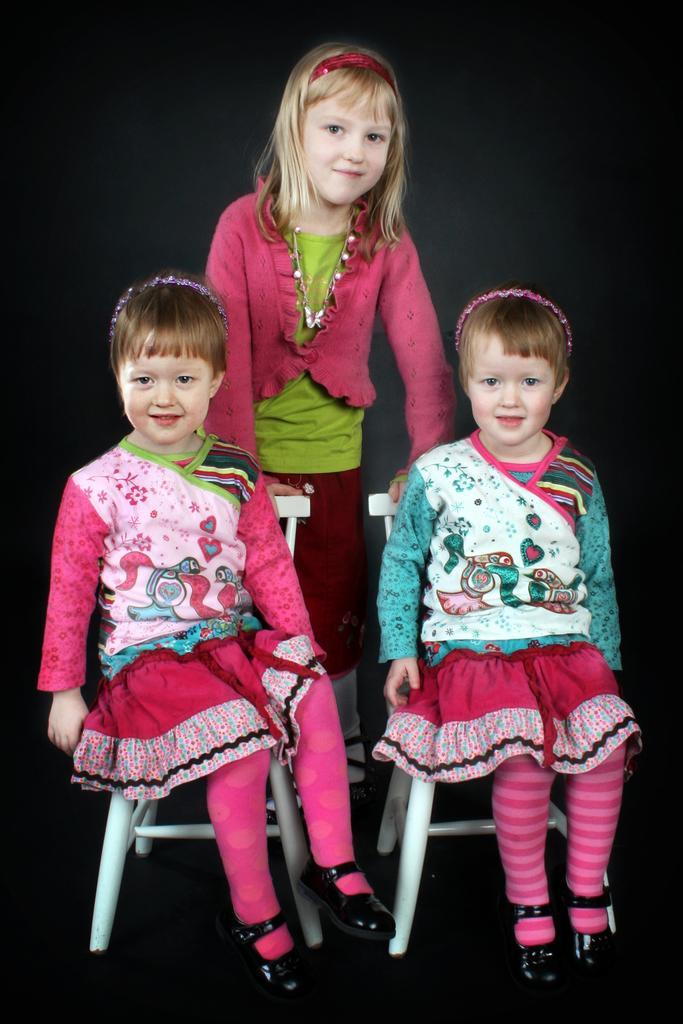In one or two sentences, can you explain what this image depicts? In the picture we can see three girls, two girls are sitting on a chairs and one girl is standing behind them and smiling, girls are wearing a pink dress and one girl is wearing a blue dress with white socks and black shoe. 